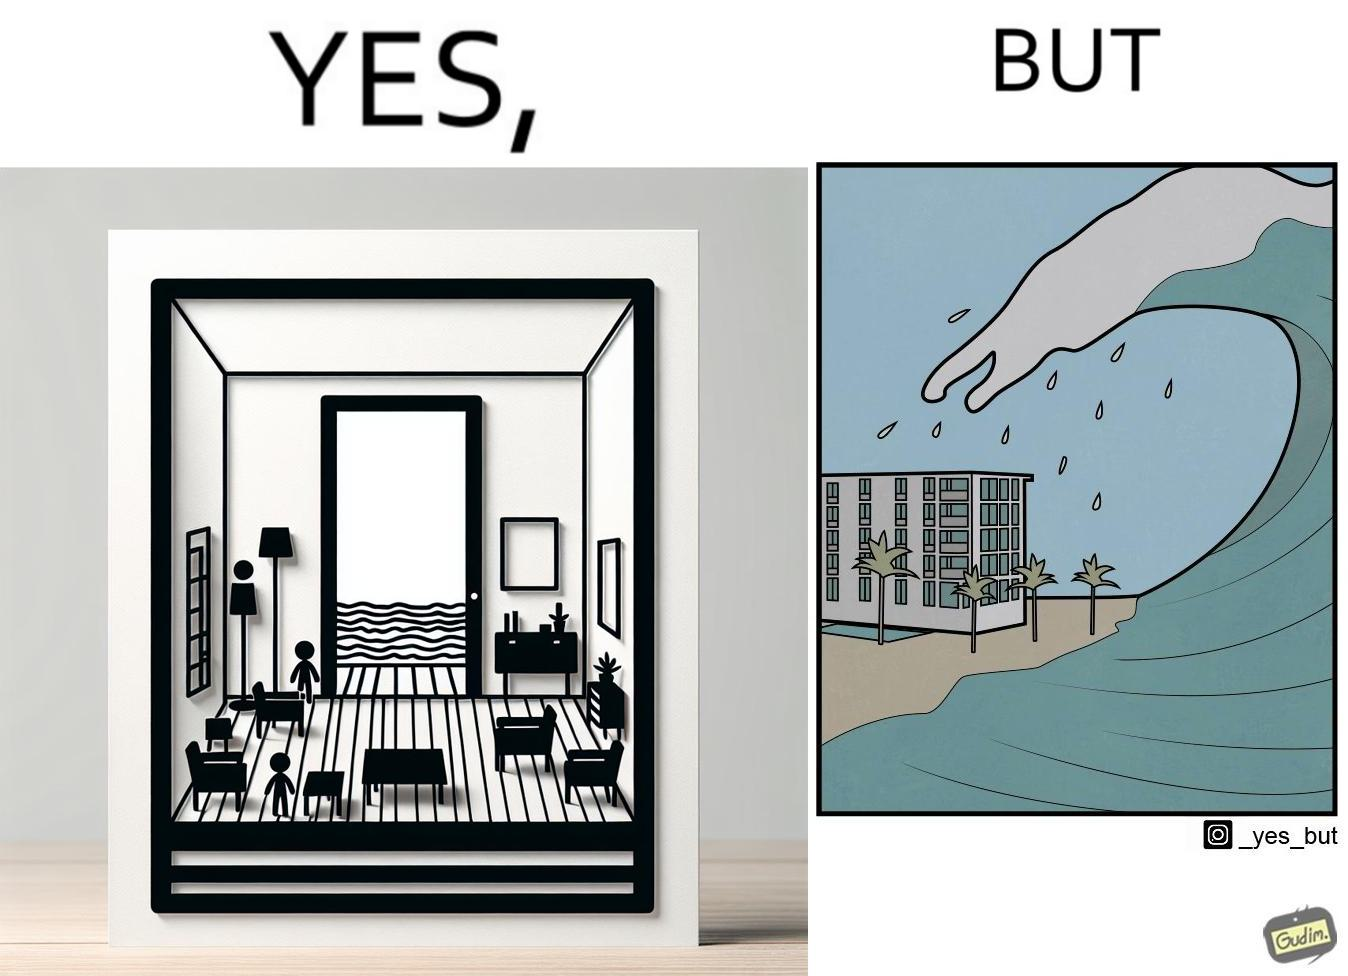Would you classify this image as satirical? Yes, this image is satirical. 